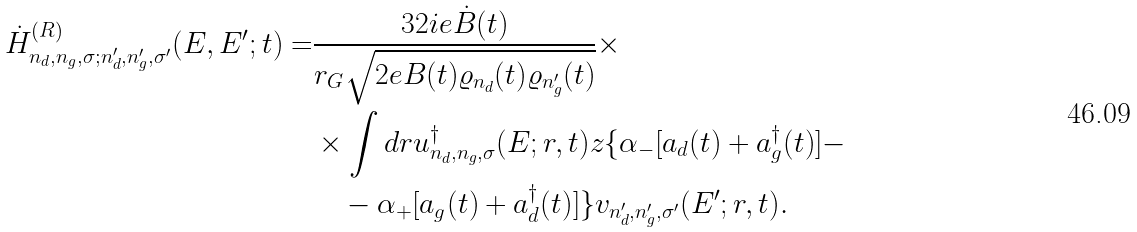Convert formula to latex. <formula><loc_0><loc_0><loc_500><loc_500>\dot { H } ^ { ( R ) } _ { n _ { d } , n _ { g } , \sigma ; n ^ { \prime } _ { d } , n ^ { \prime } _ { g } , \sigma ^ { \prime } } ( E , E ^ { \prime } ; t ) = & \frac { 3 2 i e \dot { B } ( t ) } { r _ { G } \sqrt { 2 e B ( t ) \varrho _ { n _ { d } } ( t ) \varrho _ { n ^ { \prime } _ { g } } ( t ) } } \times \\ & \times \int d r u _ { n _ { d } , n _ { g } , \sigma } ^ { \dag } ( E ; r , t ) z \{ \alpha _ { - } [ a _ { d } ( t ) + a _ { g } ^ { \dag } ( t ) ] - \\ & \quad - \alpha _ { + } [ a _ { g } ( t ) + a _ { d } ^ { \dag } ( t ) ] \} v _ { n ^ { \prime } _ { d } , n ^ { \prime } _ { g } , \sigma ^ { \prime } } ( E ^ { \prime } ; r , t ) .</formula> 